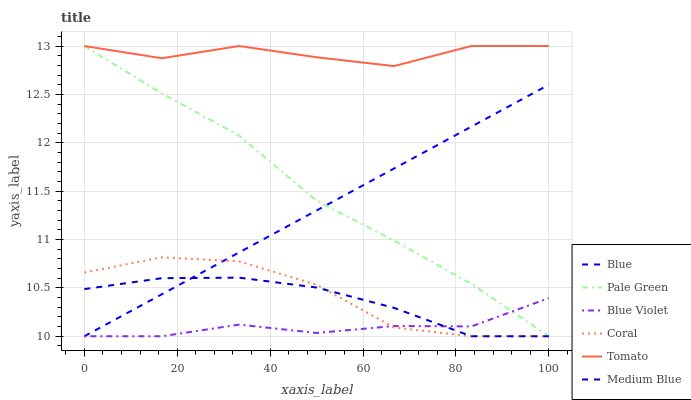Does Blue Violet have the minimum area under the curve?
Answer yes or no. Yes. Does Tomato have the maximum area under the curve?
Answer yes or no. Yes. Does Coral have the minimum area under the curve?
Answer yes or no. No. Does Coral have the maximum area under the curve?
Answer yes or no. No. Is Blue the smoothest?
Answer yes or no. Yes. Is Coral the roughest?
Answer yes or no. Yes. Is Tomato the smoothest?
Answer yes or no. No. Is Tomato the roughest?
Answer yes or no. No. Does Blue have the lowest value?
Answer yes or no. Yes. Does Tomato have the lowest value?
Answer yes or no. No. Does Pale Green have the highest value?
Answer yes or no. Yes. Does Coral have the highest value?
Answer yes or no. No. Is Medium Blue less than Tomato?
Answer yes or no. Yes. Is Tomato greater than Coral?
Answer yes or no. Yes. Does Coral intersect Blue?
Answer yes or no. Yes. Is Coral less than Blue?
Answer yes or no. No. Is Coral greater than Blue?
Answer yes or no. No. Does Medium Blue intersect Tomato?
Answer yes or no. No. 